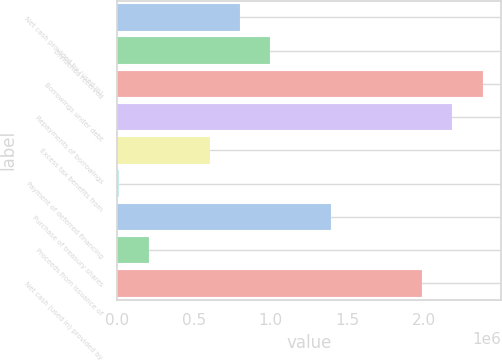Convert chart to OTSL. <chart><loc_0><loc_0><loc_500><loc_500><bar_chart><fcel>Net cash provided by (used in)<fcel>Dividends received<fcel>Borrowings under debt<fcel>Repayments of borrowings<fcel>Excess tax benefits from<fcel>Payment of deferred financing<fcel>Purchase of treasury shares<fcel>Proceeds from issuance of<fcel>Net cash (used in) provided by<nl><fcel>801670<fcel>998892<fcel>2.37944e+06<fcel>2.18222e+06<fcel>604449<fcel>12784<fcel>1.39334e+06<fcel>210006<fcel>1.985e+06<nl></chart> 